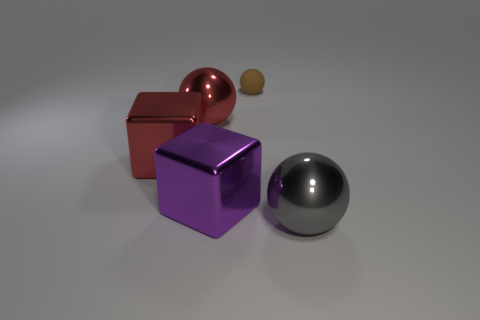If this were a still life painting, what time period could it represent? The minimalist aesthetic and clean lines suggest a modern or contemporary time period, possibly implying a futuristic setting where simplicity and form are accentuated. 